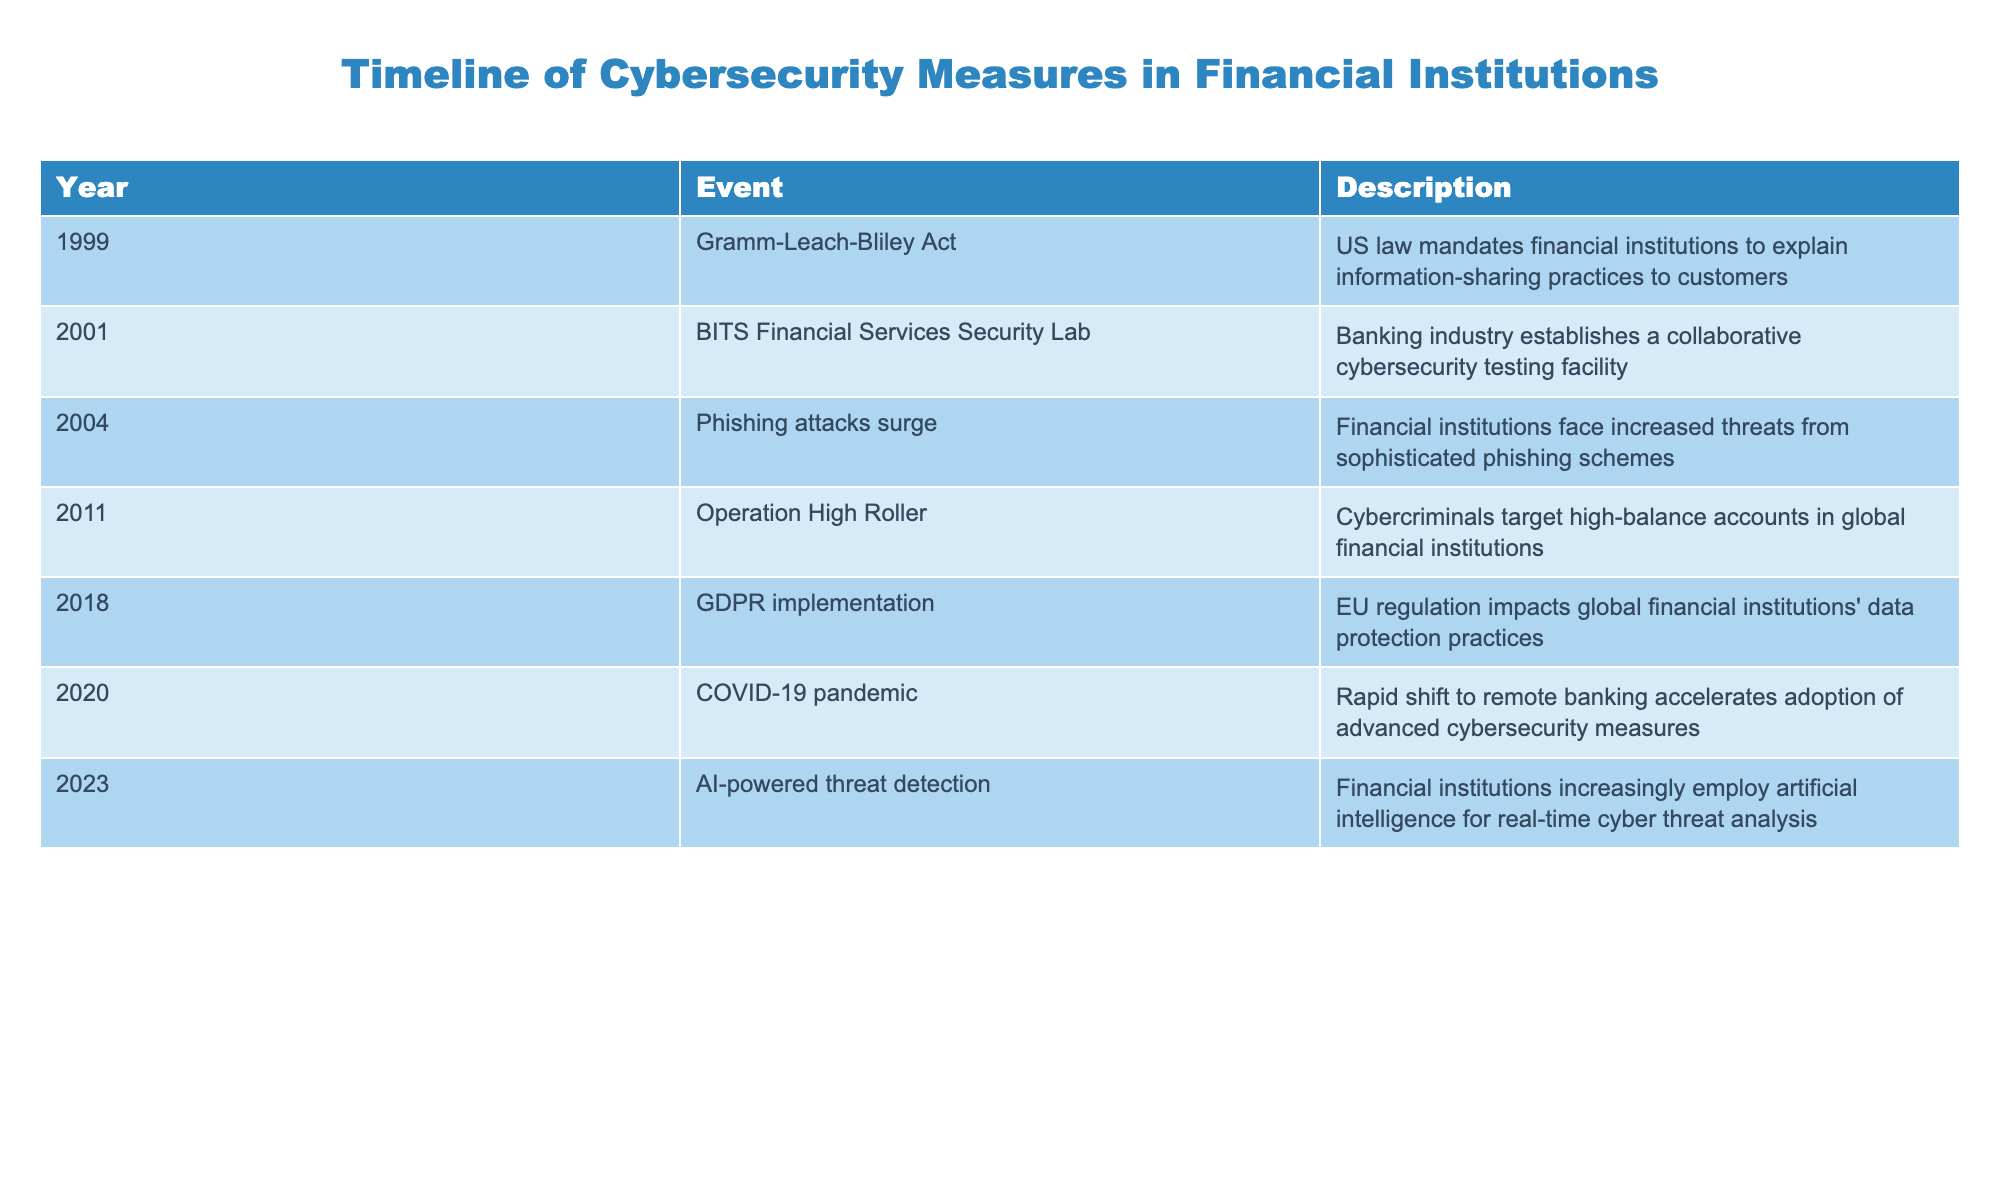What event marked a significant change in the cybersecurity landscape of financial institutions in 1999? In 1999, the Gramm-Leach-Bliley Act was enacted, which required financial institutions to explain how they share customer information. This law was a major shift as it formalized the need for data protection practices in the industry.
Answer: Gramm-Leach-Bliley Act What year did financial institutions experience a surge in phishing attacks? According to the table, phishing attacks surged in 2004, indicating that financial institutions faced increased threats from sophisticated phishing schemes that year.
Answer: 2004 Did the COVID-19 pandemic accelerate any changes in cybersecurity measures? Yes, the table states that the COVID-19 pandemic in 2020 led to a rapid shift to remote banking, which required the adoption of advanced cybersecurity measures, confirming the impact of the pandemic on cybersecurity practices.
Answer: Yes How many years apart were the implementation of the GDPR and the surge in phishing attacks? The GDPR implementation occurred in 2018, while phishing attacks surged in 2004. The difference in years is 2018 - 2004 = 14 years, indicating a significant period between these two events.
Answer: 14 years Which event indicates the involvement of artificial intelligence in cybersecurity? The event indicating the involvement of artificial intelligence is "AI-powered threat detection," noted in 2023. This suggests that financial institutions began utilizing AI for real-time cyber threat analysis to enhance their cybersecurity measures.
Answer: AI-powered threat detection What trend is evident from 2011 to 2023 regarding cybersecurity in financial institutions? From 2011, when cybercriminals targeted high-balance accounts, to 2023, with the adoption of AI-powered threat detection, there is a notable trend where cybersecurity measures have evolved from basic defenses to using advanced technologies like AI for proactive threat management.
Answer: Evolution to advanced measures What does the table list as the main focus of the BITS Financial Services Security Lab established in 2001? The BITS Financial Services Security Lab, established in 2001, was focused on creating a collaborative cybersecurity testing facility for the banking industry, indicating an industry-wide initiative to enhance security.
Answer: Collaborative cybersecurity testing Did financial institutions face similar types of cybersecurity threats consistently from 2001 to 2023? No, the threats evolved over time, starting from collaborative efforts in 2001 to sophisticated phishing attacks in 2004 and later to targeted attacks on high-balance accounts in 2011, indicating changing and increasingly complex threats over the years.
Answer: No 